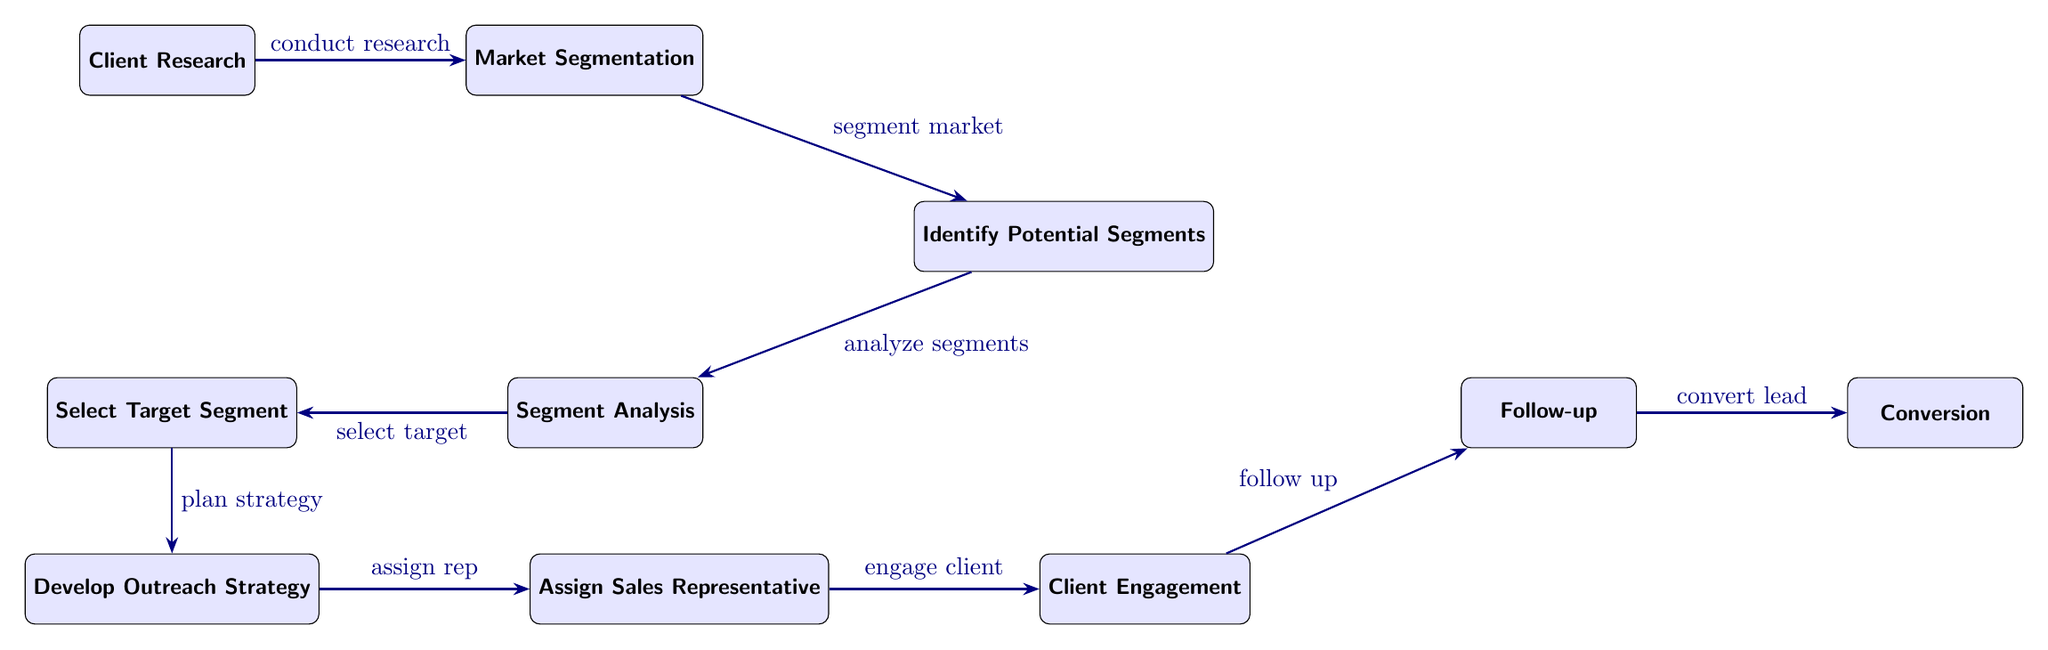What is the first step in the client acquisition process? The first step in the process is "Client Research," as indicated by the first node in the diagram.
Answer: Client Research How many nodes are in the diagram? To determine the number of nodes, we can count each distinct box, which results in a total of 9 nodes seen within the diagram.
Answer: 9 What follows market segmentation in the process? After "Market Segmentation," the next node is "Identify Potential Segments," indicating it directly follows in the flow of the process.
Answer: Identify Potential Segments Which node is located directly below the "Segment Analysis" node? The "Select Target Segment" node is directly below the "Segment Analysis" node, as the diagram structure shows it positioned below that box.
Answer: Select Target Segment What is the last step in the client acquisition process? The last step indicated in the diagram is "Conversion," which is the final node reached after all previous steps are completed.
Answer: Conversion What is the relationship between "Assign Sales Representative" and "Client Engagement"? "Assign Sales Representative" is directly linked to "Client Engagement," indicating that after assigning a representative, the next action is to engage the client.
Answer: Assign Sales Representative to Client Engagement Which two nodes are centered around the "Segment Analysis" node? The nodes "Identify Potential Segments" above and "Select Target Segment" below are both centered around "Segment Analysis." This positioning shows their relationship in the process.
Answer: Identify Potential Segments, Select Target Segment How is "Develop Outreach Strategy" related to "Select Target Segment"? "Develop Outreach Strategy" follows "Select Target Segment" in the sequence, indicating that the strategy is developed after a target segment has been selected.
Answer: Develop Outreach Strategy follows Select Target Segment Which node comes before "Follow-up"? The node that comes directly before "Follow-up" is "Client Engagement," as indicated by the arrow that connects them sequentially in the diagram.
Answer: Client Engagement 